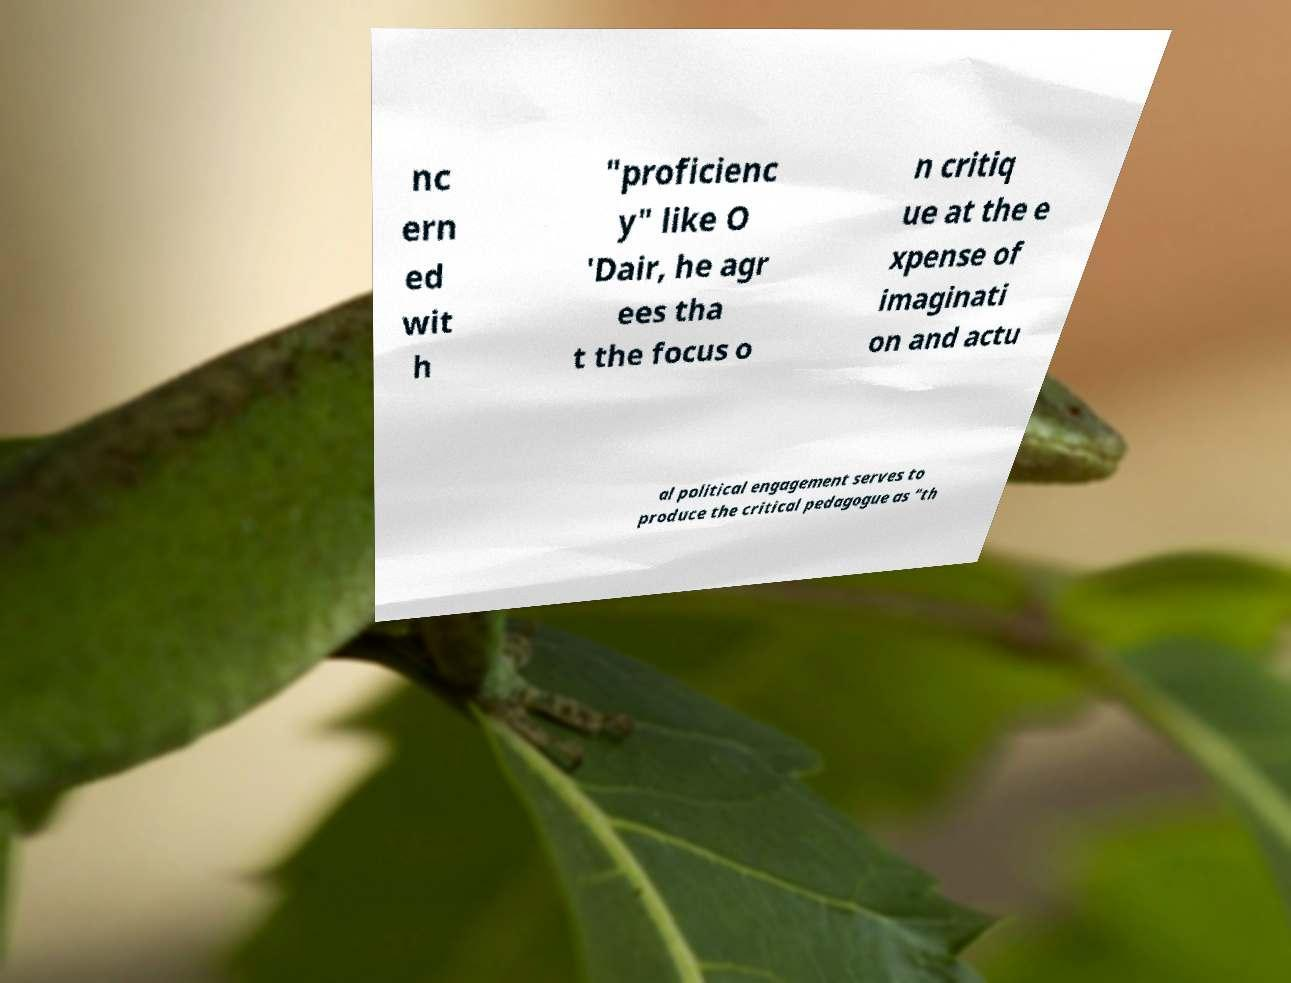For documentation purposes, I need the text within this image transcribed. Could you provide that? nc ern ed wit h "proficienc y" like O 'Dair, he agr ees tha t the focus o n critiq ue at the e xpense of imaginati on and actu al political engagement serves to produce the critical pedagogue as "th 